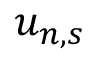Convert formula to latex. <formula><loc_0><loc_0><loc_500><loc_500>u _ { n , s }</formula> 